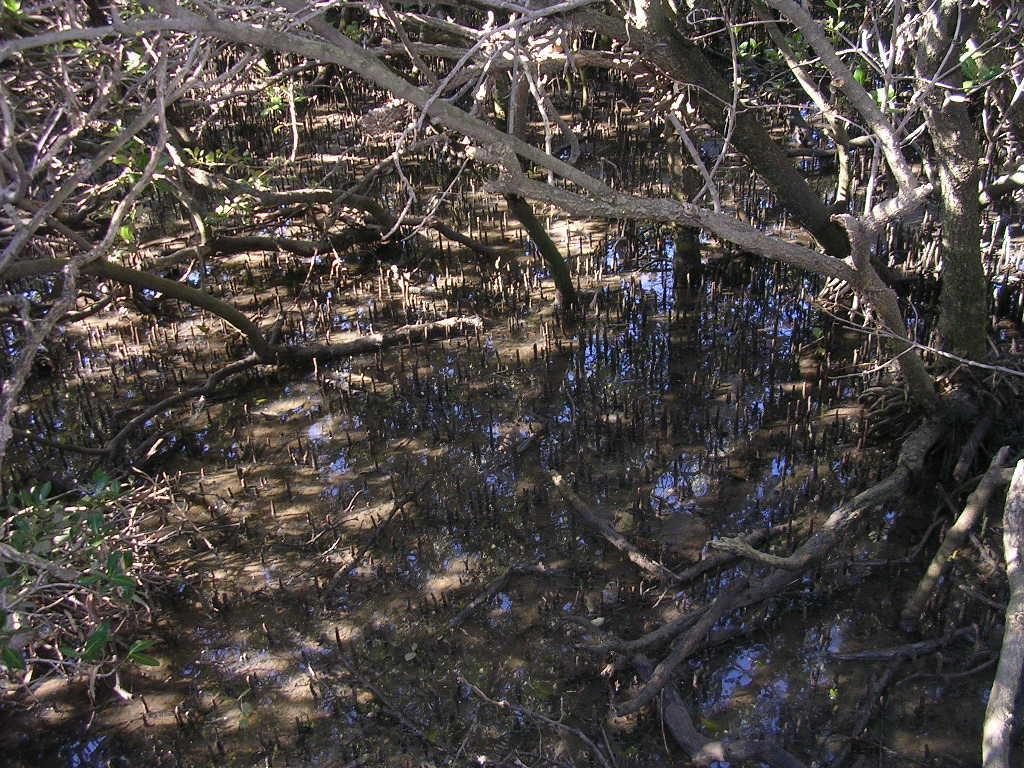What type of natural elements can be seen in the image? There are trees and water with plants in the image. Can you describe the water in the image? The water in the image has plants growing in it. Where is the library located in the image? There is no library present in the image. What type of fiction can be found in the water with plants? There is no fiction present in the image; it features natural elements such as trees and water with plants. 